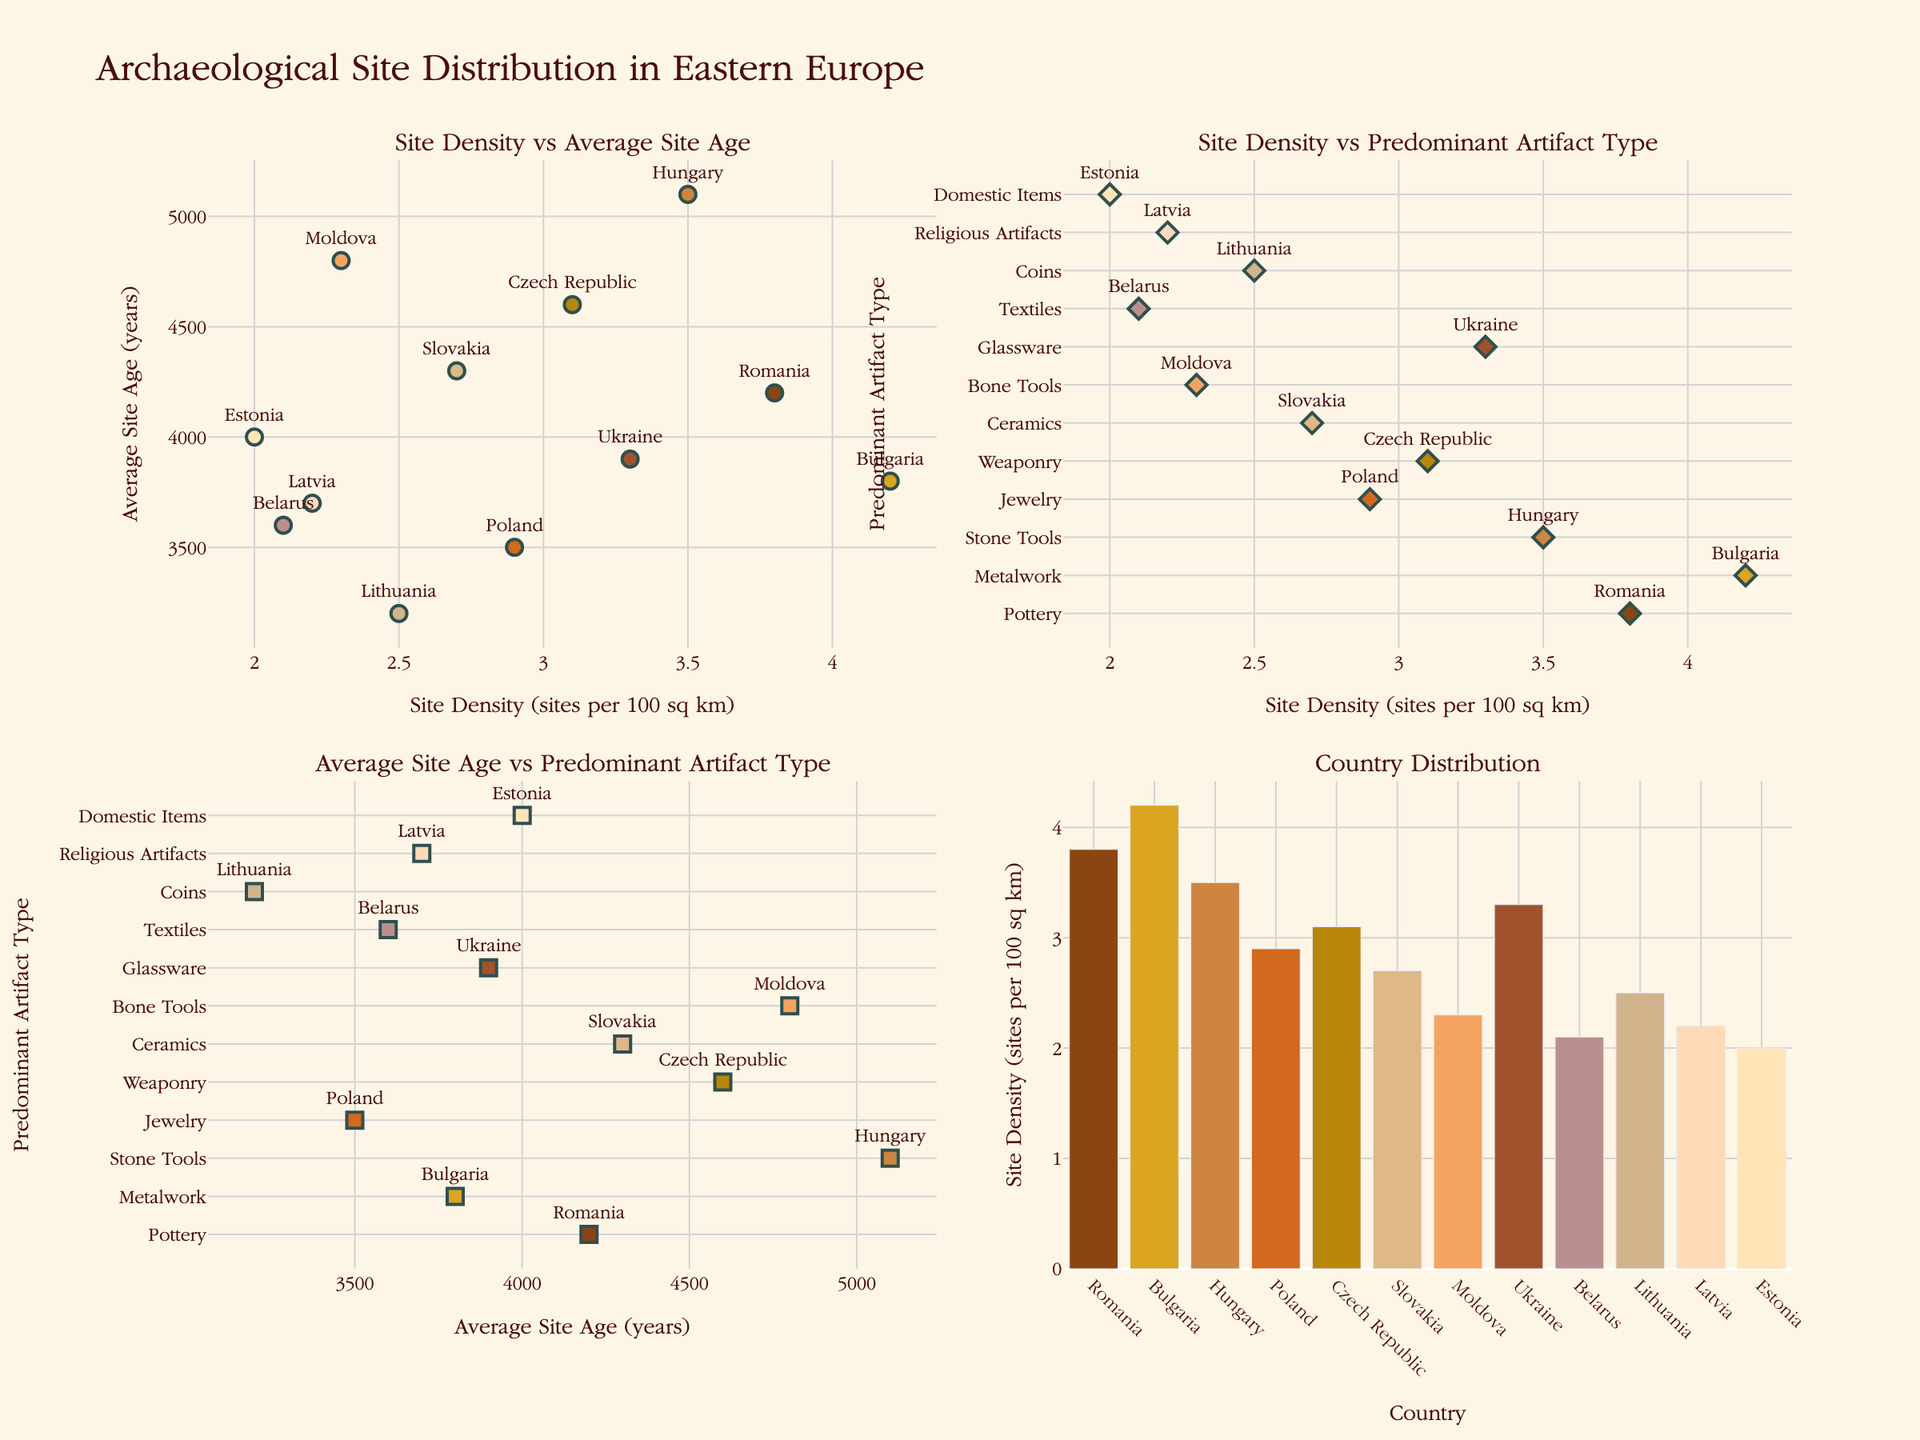What is the title of the figure? The figure's title is displayed prominently at the top.
Answer: Archaeological Site Distribution in Eastern Europe How many countries are represented in the bar plot? There are 12 bars in the "Country Distribution" subplot, each representing a country.
Answer: 12 Which country has the highest site density? In the "Country Distribution" subplot, the tallest bar corresponds to Bulgaria.
Answer: Bulgaria What is the predominant artifact type in Estonia? In the "Site Density vs Predominant Artifact Type" plot, Estonia is labeled beside "Domestic Items".
Answer: Domestic Items Which country has the oldest average site age? In the "Average Site Age vs Predominant Artifact Type" plot, Hungary has the highest value on the x-axis indicating the oldest average site age.
Answer: Hungary What is the relationship between site density and average site age for Romania? In the "Site Density vs Average Site Age" plot, Romania is plotted at around 3.8 for site density and 4200 for average site age.
Answer: 3.8 site density, 4200 years average site age Which two countries have a similar site density but different predominant artifact types? In the "Site Density vs Predominant Artifact Type" plot, Romania (Pottery) and Hungary (Stone Tools) both have site densities around 3.5.
Answer: Romania and Hungary What is the predominant artifact type in the country with the lowest site density? In the "Site Density vs Predominant Artifact Type" plot, Estonia has the lowest site density and its predominant artifact type is Domestic Items.
Answer: Domestic Items Which country has the youngest average site age and what is its predominant artifact type? In the "Average Site Age vs Predominant Artifact Type" plot, Lithuania has the lowest average site age and its predominant artifact type is Coins.
Answer: Lithuania, Coins Are there any countries with both high site density and young average site age? In the "Site Density vs Average Site Age" plot, Bulgaria has both high site density (4.2) and relatively young average site age (3800 years).
Answer: Bulgaria 